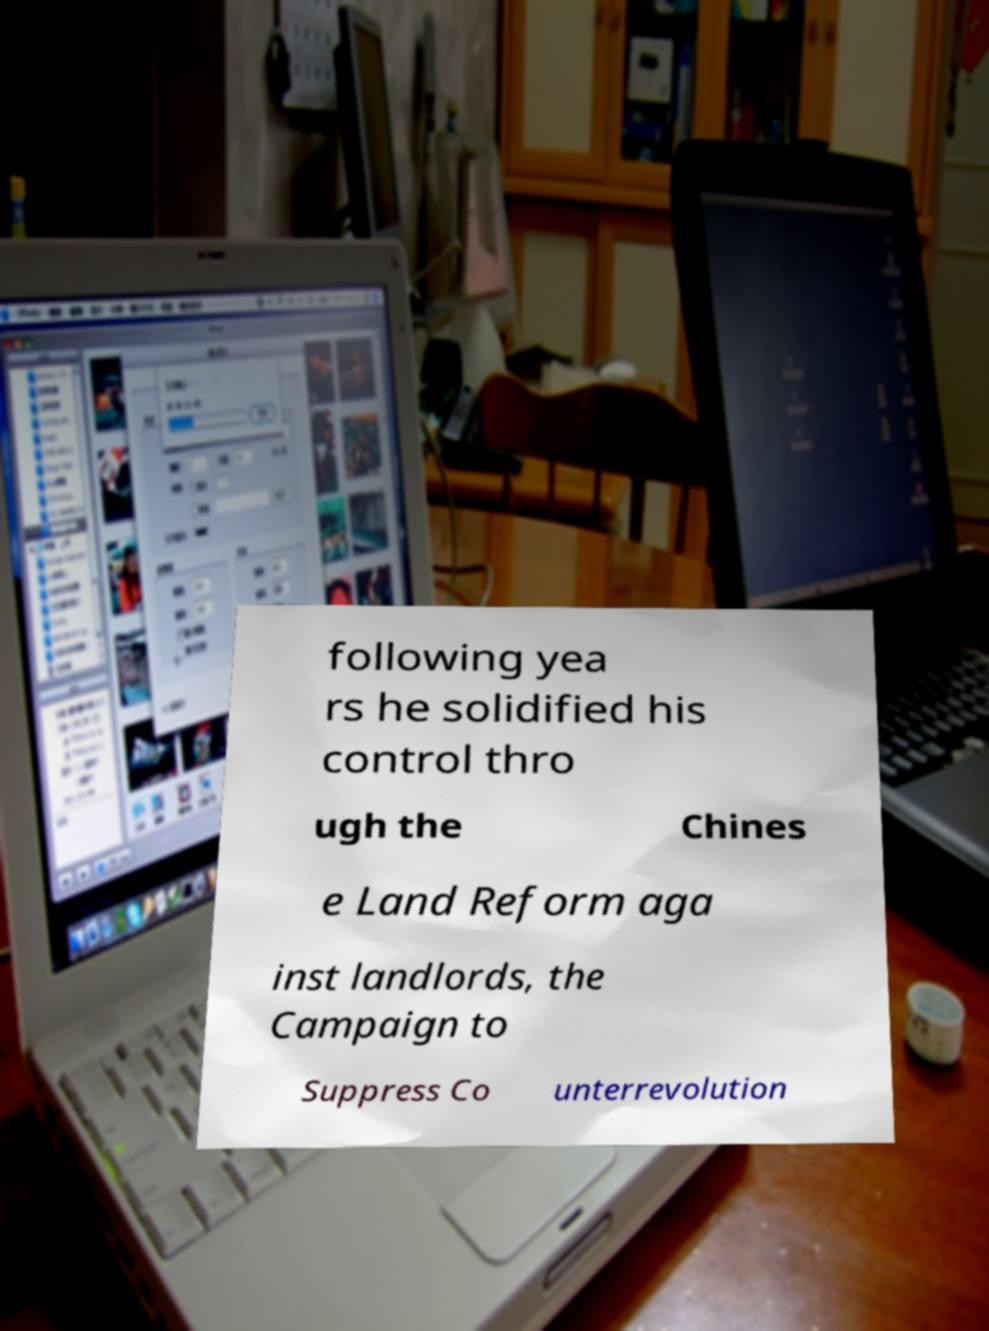Could you assist in decoding the text presented in this image and type it out clearly? following yea rs he solidified his control thro ugh the Chines e Land Reform aga inst landlords, the Campaign to Suppress Co unterrevolution 